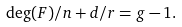Convert formula to latex. <formula><loc_0><loc_0><loc_500><loc_500>\deg ( F ) / n + d / r = g - 1 .</formula> 